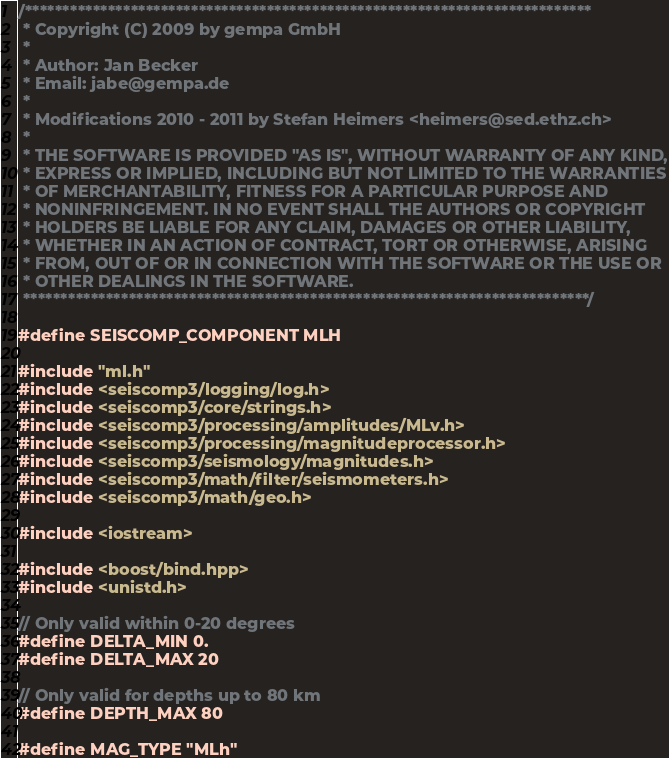Convert code to text. <code><loc_0><loc_0><loc_500><loc_500><_C++_>/***************************************************************************
 * Copyright (C) 2009 by gempa GmbH
 *
 * Author: Jan Becker
 * Email: jabe@gempa.de
 *
 * Modifications 2010 - 2011 by Stefan Heimers <heimers@sed.ethz.ch>
 *
 * THE SOFTWARE IS PROVIDED "AS IS", WITHOUT WARRANTY OF ANY KIND,
 * EXPRESS OR IMPLIED, INCLUDING BUT NOT LIMITED TO THE WARRANTIES
 * OF MERCHANTABILITY, FITNESS FOR A PARTICULAR PURPOSE AND
 * NONINFRINGEMENT. IN NO EVENT SHALL THE AUTHORS OR COPYRIGHT
 * HOLDERS BE LIABLE FOR ANY CLAIM, DAMAGES OR OTHER LIABILITY,
 * WHETHER IN AN ACTION OF CONTRACT, TORT OR OTHERWISE, ARISING
 * FROM, OUT OF OR IN CONNECTION WITH THE SOFTWARE OR THE USE OR
 * OTHER DEALINGS IN THE SOFTWARE.
 ***************************************************************************/

#define SEISCOMP_COMPONENT MLH

#include "ml.h"
#include <seiscomp3/logging/log.h>
#include <seiscomp3/core/strings.h>
#include <seiscomp3/processing/amplitudes/MLv.h>
#include <seiscomp3/processing/magnitudeprocessor.h>
#include <seiscomp3/seismology/magnitudes.h>
#include <seiscomp3/math/filter/seismometers.h>
#include <seiscomp3/math/geo.h>

#include <iostream>

#include <boost/bind.hpp>
#include <unistd.h>

// Only valid within 0-20 degrees
#define DELTA_MIN 0.
#define DELTA_MAX 20

// Only valid for depths up to 80 km
#define DEPTH_MAX 80

#define MAG_TYPE "MLh"
</code> 